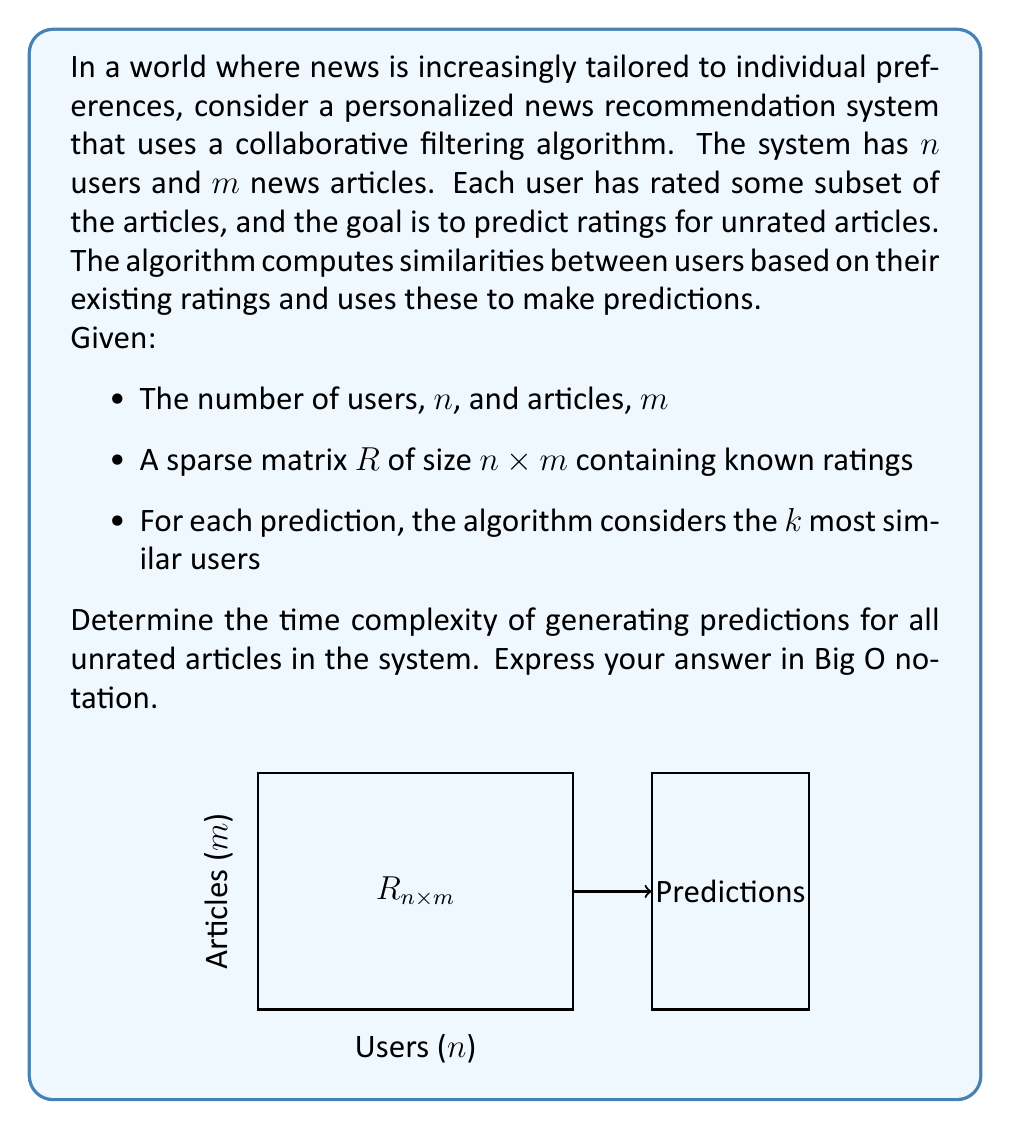Solve this math problem. To determine the time complexity, let's break down the algorithm into steps:

1) For each unrated article (worst case $O(nm)$ iterations):
   a) Find $k$ most similar users:
      - Compute similarity with all other users: $O(nm)$ (comparing rating vectors)
      - Sort users by similarity: $O(n \log n)$
      - Select top $k$: $O(k)$
   b) Predict rating based on $k$ users: $O(k)$

2) The dominant operations for each prediction are:
   - Computing similarities: $O(nm)$
   - Sorting: $O(n \log n)$

3) Total complexity for all predictions:
   $O(nm \cdot (nm + n \log n))$

4) Simplify:
   $O(n^2m^2 + n^2m \log n)$

5) Since $m$ could be larger than $\log n$, we can further simplify:
   $O(n^2m^2)$

This quadratic complexity in both $n$ and $m$ reflects the challenge of personalizing news at scale, mirroring the difficulty of maintaining objectivity in modern digital news reporting.
Answer: $O(n^2m^2)$ 